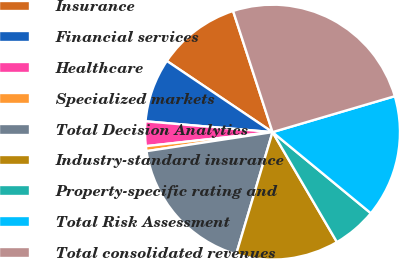<chart> <loc_0><loc_0><loc_500><loc_500><pie_chart><fcel>Insurance<fcel>Financial services<fcel>Healthcare<fcel>Specialized markets<fcel>Total Decision Analytics<fcel>Industry-standard insurance<fcel>Property-specific rating and<fcel>Total Risk Assessment<fcel>Total consolidated revenues<nl><fcel>10.56%<fcel>8.08%<fcel>3.11%<fcel>0.63%<fcel>18.01%<fcel>13.04%<fcel>5.59%<fcel>15.53%<fcel>25.46%<nl></chart> 